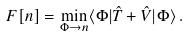<formula> <loc_0><loc_0><loc_500><loc_500>F [ n ] = \min _ { \Phi \rightarrow n } \langle \Phi | \hat { T } + \hat { V } | \Phi \rangle \, .</formula> 